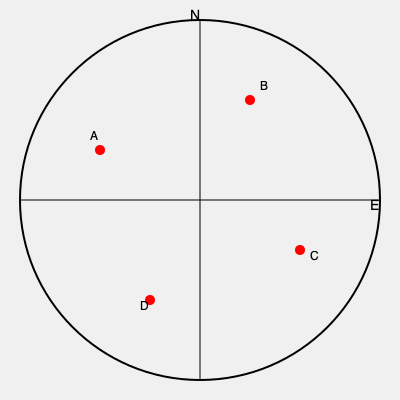Given the map of London above with reported ghost sightings marked as red dots (A, B, C, and D), what is the total area of the circular region that encompasses all sightings, assuming the map scale is 1:100,000 and the diameter of the circle is 10 cm on the map? To solve this problem, we need to follow these steps:

1. Understand the map scale:
   - Scale is 1:100,000, meaning 1 cm on the map represents 100,000 cm (1 km) in reality.

2. Calculate the actual diameter of the circle:
   - Diameter on map = 10 cm
   - Actual diameter = 10 cm × 100,000 = 1,000,000 cm = 10 km

3. Calculate the radius of the circle:
   - Radius = Diameter ÷ 2
   - Radius = 10 km ÷ 2 = 5 km

4. Use the formula for the area of a circle:
   - Area = $\pi r^2$
   - Where $r$ is the radius in km

5. Calculate the area:
   - Area = $\pi \times (5 \text{ km})^2$
   - Area = $\pi \times 25 \text{ km}^2$
   - Area ≈ 78.54 km²

Therefore, the total area of the circular region encompassing all ghost sightings is approximately 78.54 square kilometers.
Answer: 78.54 km² 